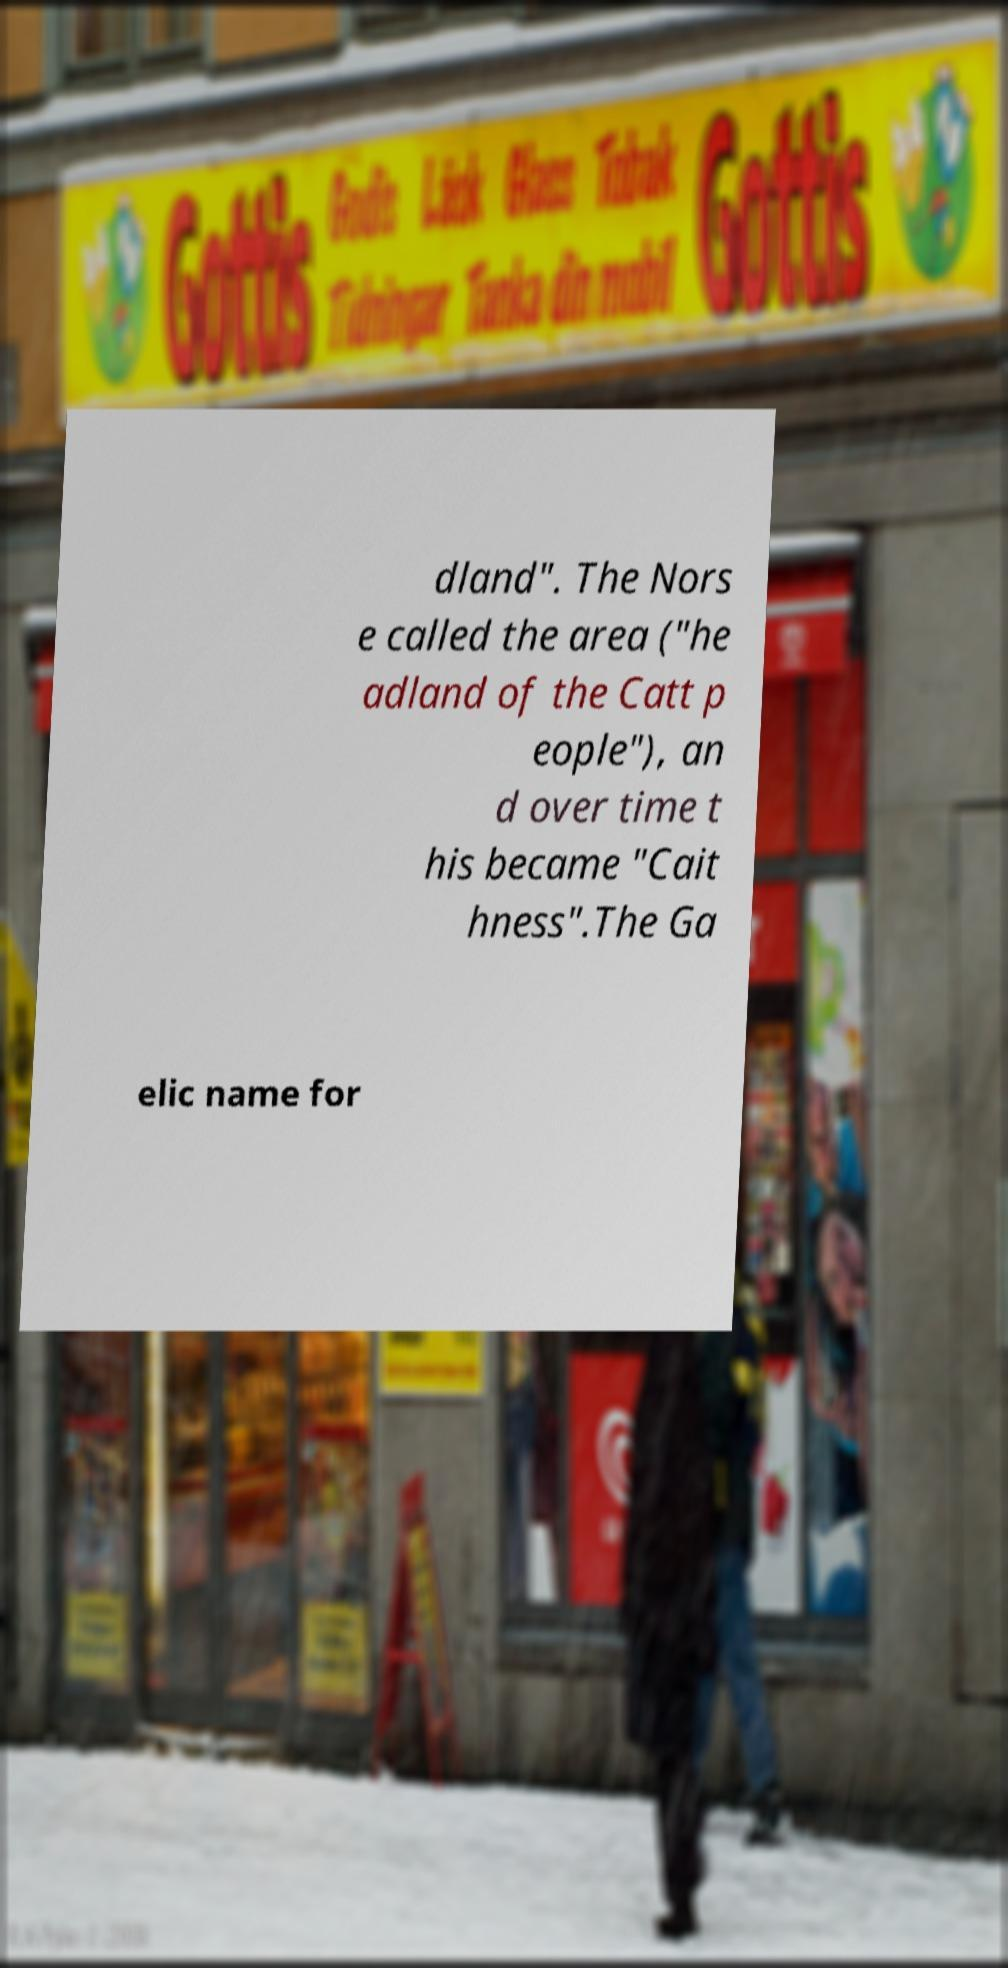What messages or text are displayed in this image? I need them in a readable, typed format. dland". The Nors e called the area ("he adland of the Catt p eople"), an d over time t his became "Cait hness".The Ga elic name for 